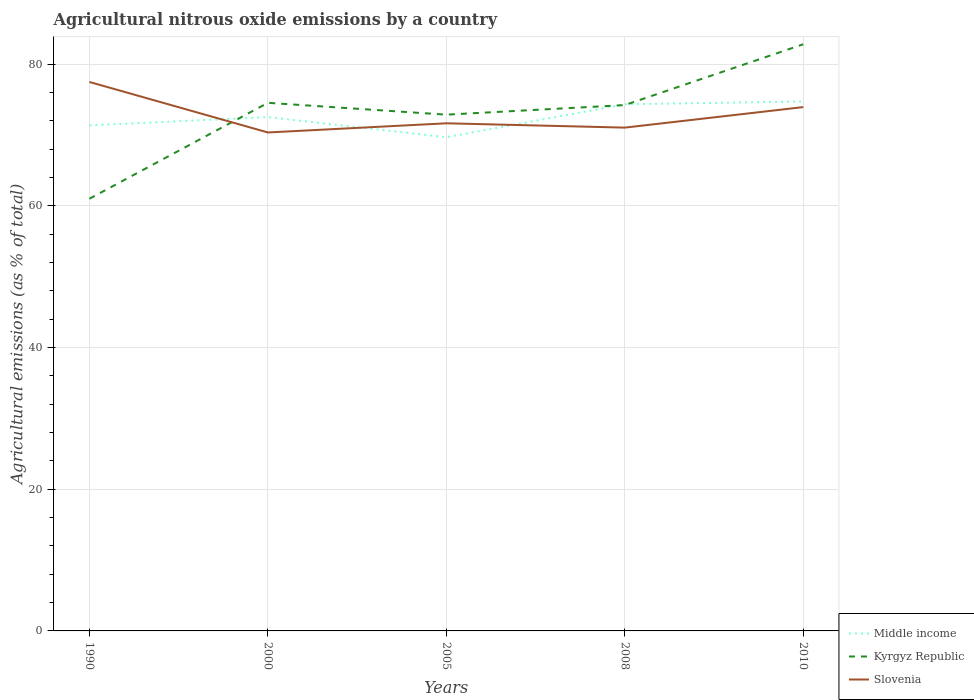How many different coloured lines are there?
Offer a very short reply. 3. Is the number of lines equal to the number of legend labels?
Offer a terse response. Yes. Across all years, what is the maximum amount of agricultural nitrous oxide emitted in Slovenia?
Offer a terse response. 70.37. What is the total amount of agricultural nitrous oxide emitted in Slovenia in the graph?
Your response must be concise. 3.55. What is the difference between the highest and the second highest amount of agricultural nitrous oxide emitted in Kyrgyz Republic?
Your answer should be compact. 21.8. How many years are there in the graph?
Offer a terse response. 5. Does the graph contain any zero values?
Offer a very short reply. No. Does the graph contain grids?
Offer a terse response. Yes. Where does the legend appear in the graph?
Make the answer very short. Bottom right. How many legend labels are there?
Your response must be concise. 3. What is the title of the graph?
Ensure brevity in your answer.  Agricultural nitrous oxide emissions by a country. Does "Guatemala" appear as one of the legend labels in the graph?
Your answer should be compact. No. What is the label or title of the X-axis?
Provide a succinct answer. Years. What is the label or title of the Y-axis?
Keep it short and to the point. Agricultural emissions (as % of total). What is the Agricultural emissions (as % of total) of Middle income in 1990?
Provide a short and direct response. 71.38. What is the Agricultural emissions (as % of total) in Kyrgyz Republic in 1990?
Provide a short and direct response. 61.01. What is the Agricultural emissions (as % of total) in Slovenia in 1990?
Make the answer very short. 77.5. What is the Agricultural emissions (as % of total) in Middle income in 2000?
Provide a succinct answer. 72.54. What is the Agricultural emissions (as % of total) in Kyrgyz Republic in 2000?
Offer a terse response. 74.56. What is the Agricultural emissions (as % of total) in Slovenia in 2000?
Offer a terse response. 70.37. What is the Agricultural emissions (as % of total) of Middle income in 2005?
Ensure brevity in your answer.  69.7. What is the Agricultural emissions (as % of total) of Kyrgyz Republic in 2005?
Your answer should be compact. 72.88. What is the Agricultural emissions (as % of total) in Slovenia in 2005?
Keep it short and to the point. 71.67. What is the Agricultural emissions (as % of total) in Middle income in 2008?
Offer a terse response. 74.35. What is the Agricultural emissions (as % of total) of Kyrgyz Republic in 2008?
Provide a short and direct response. 74.24. What is the Agricultural emissions (as % of total) of Slovenia in 2008?
Ensure brevity in your answer.  71.06. What is the Agricultural emissions (as % of total) in Middle income in 2010?
Ensure brevity in your answer.  74.75. What is the Agricultural emissions (as % of total) in Kyrgyz Republic in 2010?
Give a very brief answer. 82.82. What is the Agricultural emissions (as % of total) in Slovenia in 2010?
Give a very brief answer. 73.95. Across all years, what is the maximum Agricultural emissions (as % of total) in Middle income?
Provide a succinct answer. 74.75. Across all years, what is the maximum Agricultural emissions (as % of total) of Kyrgyz Republic?
Your response must be concise. 82.82. Across all years, what is the maximum Agricultural emissions (as % of total) of Slovenia?
Your answer should be compact. 77.5. Across all years, what is the minimum Agricultural emissions (as % of total) in Middle income?
Provide a short and direct response. 69.7. Across all years, what is the minimum Agricultural emissions (as % of total) of Kyrgyz Republic?
Your answer should be compact. 61.01. Across all years, what is the minimum Agricultural emissions (as % of total) in Slovenia?
Offer a very short reply. 70.37. What is the total Agricultural emissions (as % of total) in Middle income in the graph?
Offer a very short reply. 362.72. What is the total Agricultural emissions (as % of total) of Kyrgyz Republic in the graph?
Your answer should be compact. 365.51. What is the total Agricultural emissions (as % of total) in Slovenia in the graph?
Offer a terse response. 364.55. What is the difference between the Agricultural emissions (as % of total) of Middle income in 1990 and that in 2000?
Your answer should be compact. -1.17. What is the difference between the Agricultural emissions (as % of total) of Kyrgyz Republic in 1990 and that in 2000?
Provide a succinct answer. -13.54. What is the difference between the Agricultural emissions (as % of total) in Slovenia in 1990 and that in 2000?
Offer a very short reply. 7.13. What is the difference between the Agricultural emissions (as % of total) in Middle income in 1990 and that in 2005?
Your response must be concise. 1.68. What is the difference between the Agricultural emissions (as % of total) of Kyrgyz Republic in 1990 and that in 2005?
Ensure brevity in your answer.  -11.87. What is the difference between the Agricultural emissions (as % of total) of Slovenia in 1990 and that in 2005?
Your response must be concise. 5.84. What is the difference between the Agricultural emissions (as % of total) in Middle income in 1990 and that in 2008?
Offer a very short reply. -2.97. What is the difference between the Agricultural emissions (as % of total) of Kyrgyz Republic in 1990 and that in 2008?
Offer a very short reply. -13.22. What is the difference between the Agricultural emissions (as % of total) in Slovenia in 1990 and that in 2008?
Provide a short and direct response. 6.45. What is the difference between the Agricultural emissions (as % of total) in Middle income in 1990 and that in 2010?
Offer a terse response. -3.37. What is the difference between the Agricultural emissions (as % of total) in Kyrgyz Republic in 1990 and that in 2010?
Provide a short and direct response. -21.8. What is the difference between the Agricultural emissions (as % of total) of Slovenia in 1990 and that in 2010?
Provide a succinct answer. 3.55. What is the difference between the Agricultural emissions (as % of total) of Middle income in 2000 and that in 2005?
Your answer should be compact. 2.84. What is the difference between the Agricultural emissions (as % of total) of Kyrgyz Republic in 2000 and that in 2005?
Your answer should be compact. 1.67. What is the difference between the Agricultural emissions (as % of total) of Slovenia in 2000 and that in 2005?
Provide a succinct answer. -1.29. What is the difference between the Agricultural emissions (as % of total) in Middle income in 2000 and that in 2008?
Offer a terse response. -1.8. What is the difference between the Agricultural emissions (as % of total) in Kyrgyz Republic in 2000 and that in 2008?
Give a very brief answer. 0.32. What is the difference between the Agricultural emissions (as % of total) of Slovenia in 2000 and that in 2008?
Your answer should be compact. -0.68. What is the difference between the Agricultural emissions (as % of total) of Middle income in 2000 and that in 2010?
Keep it short and to the point. -2.21. What is the difference between the Agricultural emissions (as % of total) in Kyrgyz Republic in 2000 and that in 2010?
Your answer should be compact. -8.26. What is the difference between the Agricultural emissions (as % of total) in Slovenia in 2000 and that in 2010?
Offer a terse response. -3.58. What is the difference between the Agricultural emissions (as % of total) of Middle income in 2005 and that in 2008?
Your response must be concise. -4.64. What is the difference between the Agricultural emissions (as % of total) in Kyrgyz Republic in 2005 and that in 2008?
Give a very brief answer. -1.35. What is the difference between the Agricultural emissions (as % of total) in Slovenia in 2005 and that in 2008?
Make the answer very short. 0.61. What is the difference between the Agricultural emissions (as % of total) in Middle income in 2005 and that in 2010?
Offer a terse response. -5.05. What is the difference between the Agricultural emissions (as % of total) of Kyrgyz Republic in 2005 and that in 2010?
Make the answer very short. -9.93. What is the difference between the Agricultural emissions (as % of total) in Slovenia in 2005 and that in 2010?
Give a very brief answer. -2.29. What is the difference between the Agricultural emissions (as % of total) in Middle income in 2008 and that in 2010?
Ensure brevity in your answer.  -0.4. What is the difference between the Agricultural emissions (as % of total) of Kyrgyz Republic in 2008 and that in 2010?
Offer a terse response. -8.58. What is the difference between the Agricultural emissions (as % of total) of Slovenia in 2008 and that in 2010?
Provide a short and direct response. -2.9. What is the difference between the Agricultural emissions (as % of total) of Middle income in 1990 and the Agricultural emissions (as % of total) of Kyrgyz Republic in 2000?
Ensure brevity in your answer.  -3.18. What is the difference between the Agricultural emissions (as % of total) of Middle income in 1990 and the Agricultural emissions (as % of total) of Slovenia in 2000?
Offer a terse response. 1.01. What is the difference between the Agricultural emissions (as % of total) of Kyrgyz Republic in 1990 and the Agricultural emissions (as % of total) of Slovenia in 2000?
Keep it short and to the point. -9.36. What is the difference between the Agricultural emissions (as % of total) of Middle income in 1990 and the Agricultural emissions (as % of total) of Kyrgyz Republic in 2005?
Ensure brevity in your answer.  -1.51. What is the difference between the Agricultural emissions (as % of total) in Middle income in 1990 and the Agricultural emissions (as % of total) in Slovenia in 2005?
Offer a terse response. -0.29. What is the difference between the Agricultural emissions (as % of total) in Kyrgyz Republic in 1990 and the Agricultural emissions (as % of total) in Slovenia in 2005?
Your answer should be compact. -10.65. What is the difference between the Agricultural emissions (as % of total) in Middle income in 1990 and the Agricultural emissions (as % of total) in Kyrgyz Republic in 2008?
Your response must be concise. -2.86. What is the difference between the Agricultural emissions (as % of total) in Middle income in 1990 and the Agricultural emissions (as % of total) in Slovenia in 2008?
Offer a very short reply. 0.32. What is the difference between the Agricultural emissions (as % of total) in Kyrgyz Republic in 1990 and the Agricultural emissions (as % of total) in Slovenia in 2008?
Give a very brief answer. -10.04. What is the difference between the Agricultural emissions (as % of total) in Middle income in 1990 and the Agricultural emissions (as % of total) in Kyrgyz Republic in 2010?
Provide a short and direct response. -11.44. What is the difference between the Agricultural emissions (as % of total) in Middle income in 1990 and the Agricultural emissions (as % of total) in Slovenia in 2010?
Provide a short and direct response. -2.57. What is the difference between the Agricultural emissions (as % of total) of Kyrgyz Republic in 1990 and the Agricultural emissions (as % of total) of Slovenia in 2010?
Offer a terse response. -12.94. What is the difference between the Agricultural emissions (as % of total) of Middle income in 2000 and the Agricultural emissions (as % of total) of Kyrgyz Republic in 2005?
Provide a short and direct response. -0.34. What is the difference between the Agricultural emissions (as % of total) of Middle income in 2000 and the Agricultural emissions (as % of total) of Slovenia in 2005?
Give a very brief answer. 0.88. What is the difference between the Agricultural emissions (as % of total) of Kyrgyz Republic in 2000 and the Agricultural emissions (as % of total) of Slovenia in 2005?
Your answer should be compact. 2.89. What is the difference between the Agricultural emissions (as % of total) of Middle income in 2000 and the Agricultural emissions (as % of total) of Kyrgyz Republic in 2008?
Offer a terse response. -1.69. What is the difference between the Agricultural emissions (as % of total) in Middle income in 2000 and the Agricultural emissions (as % of total) in Slovenia in 2008?
Your response must be concise. 1.49. What is the difference between the Agricultural emissions (as % of total) of Kyrgyz Republic in 2000 and the Agricultural emissions (as % of total) of Slovenia in 2008?
Ensure brevity in your answer.  3.5. What is the difference between the Agricultural emissions (as % of total) in Middle income in 2000 and the Agricultural emissions (as % of total) in Kyrgyz Republic in 2010?
Your response must be concise. -10.28. What is the difference between the Agricultural emissions (as % of total) of Middle income in 2000 and the Agricultural emissions (as % of total) of Slovenia in 2010?
Your answer should be very brief. -1.41. What is the difference between the Agricultural emissions (as % of total) of Kyrgyz Republic in 2000 and the Agricultural emissions (as % of total) of Slovenia in 2010?
Ensure brevity in your answer.  0.6. What is the difference between the Agricultural emissions (as % of total) of Middle income in 2005 and the Agricultural emissions (as % of total) of Kyrgyz Republic in 2008?
Your response must be concise. -4.54. What is the difference between the Agricultural emissions (as % of total) in Middle income in 2005 and the Agricultural emissions (as % of total) in Slovenia in 2008?
Your response must be concise. -1.35. What is the difference between the Agricultural emissions (as % of total) of Kyrgyz Republic in 2005 and the Agricultural emissions (as % of total) of Slovenia in 2008?
Keep it short and to the point. 1.83. What is the difference between the Agricultural emissions (as % of total) in Middle income in 2005 and the Agricultural emissions (as % of total) in Kyrgyz Republic in 2010?
Your answer should be very brief. -13.12. What is the difference between the Agricultural emissions (as % of total) of Middle income in 2005 and the Agricultural emissions (as % of total) of Slovenia in 2010?
Your answer should be compact. -4.25. What is the difference between the Agricultural emissions (as % of total) in Kyrgyz Republic in 2005 and the Agricultural emissions (as % of total) in Slovenia in 2010?
Offer a terse response. -1.07. What is the difference between the Agricultural emissions (as % of total) in Middle income in 2008 and the Agricultural emissions (as % of total) in Kyrgyz Republic in 2010?
Offer a terse response. -8.47. What is the difference between the Agricultural emissions (as % of total) in Middle income in 2008 and the Agricultural emissions (as % of total) in Slovenia in 2010?
Ensure brevity in your answer.  0.39. What is the difference between the Agricultural emissions (as % of total) in Kyrgyz Republic in 2008 and the Agricultural emissions (as % of total) in Slovenia in 2010?
Offer a terse response. 0.29. What is the average Agricultural emissions (as % of total) of Middle income per year?
Provide a succinct answer. 72.54. What is the average Agricultural emissions (as % of total) in Kyrgyz Republic per year?
Provide a succinct answer. 73.1. What is the average Agricultural emissions (as % of total) in Slovenia per year?
Make the answer very short. 72.91. In the year 1990, what is the difference between the Agricultural emissions (as % of total) of Middle income and Agricultural emissions (as % of total) of Kyrgyz Republic?
Keep it short and to the point. 10.36. In the year 1990, what is the difference between the Agricultural emissions (as % of total) in Middle income and Agricultural emissions (as % of total) in Slovenia?
Provide a succinct answer. -6.12. In the year 1990, what is the difference between the Agricultural emissions (as % of total) of Kyrgyz Republic and Agricultural emissions (as % of total) of Slovenia?
Provide a succinct answer. -16.49. In the year 2000, what is the difference between the Agricultural emissions (as % of total) in Middle income and Agricultural emissions (as % of total) in Kyrgyz Republic?
Offer a terse response. -2.01. In the year 2000, what is the difference between the Agricultural emissions (as % of total) in Middle income and Agricultural emissions (as % of total) in Slovenia?
Keep it short and to the point. 2.17. In the year 2000, what is the difference between the Agricultural emissions (as % of total) in Kyrgyz Republic and Agricultural emissions (as % of total) in Slovenia?
Your answer should be compact. 4.18. In the year 2005, what is the difference between the Agricultural emissions (as % of total) in Middle income and Agricultural emissions (as % of total) in Kyrgyz Republic?
Make the answer very short. -3.18. In the year 2005, what is the difference between the Agricultural emissions (as % of total) in Middle income and Agricultural emissions (as % of total) in Slovenia?
Your answer should be very brief. -1.96. In the year 2005, what is the difference between the Agricultural emissions (as % of total) in Kyrgyz Republic and Agricultural emissions (as % of total) in Slovenia?
Keep it short and to the point. 1.22. In the year 2008, what is the difference between the Agricultural emissions (as % of total) in Middle income and Agricultural emissions (as % of total) in Kyrgyz Republic?
Your answer should be very brief. 0.11. In the year 2008, what is the difference between the Agricultural emissions (as % of total) of Middle income and Agricultural emissions (as % of total) of Slovenia?
Offer a terse response. 3.29. In the year 2008, what is the difference between the Agricultural emissions (as % of total) in Kyrgyz Republic and Agricultural emissions (as % of total) in Slovenia?
Provide a short and direct response. 3.18. In the year 2010, what is the difference between the Agricultural emissions (as % of total) of Middle income and Agricultural emissions (as % of total) of Kyrgyz Republic?
Offer a terse response. -8.07. In the year 2010, what is the difference between the Agricultural emissions (as % of total) in Middle income and Agricultural emissions (as % of total) in Slovenia?
Keep it short and to the point. 0.8. In the year 2010, what is the difference between the Agricultural emissions (as % of total) of Kyrgyz Republic and Agricultural emissions (as % of total) of Slovenia?
Your answer should be compact. 8.87. What is the ratio of the Agricultural emissions (as % of total) in Middle income in 1990 to that in 2000?
Your answer should be compact. 0.98. What is the ratio of the Agricultural emissions (as % of total) in Kyrgyz Republic in 1990 to that in 2000?
Make the answer very short. 0.82. What is the ratio of the Agricultural emissions (as % of total) in Slovenia in 1990 to that in 2000?
Your answer should be very brief. 1.1. What is the ratio of the Agricultural emissions (as % of total) of Middle income in 1990 to that in 2005?
Offer a terse response. 1.02. What is the ratio of the Agricultural emissions (as % of total) of Kyrgyz Republic in 1990 to that in 2005?
Offer a very short reply. 0.84. What is the ratio of the Agricultural emissions (as % of total) in Slovenia in 1990 to that in 2005?
Provide a short and direct response. 1.08. What is the ratio of the Agricultural emissions (as % of total) of Middle income in 1990 to that in 2008?
Give a very brief answer. 0.96. What is the ratio of the Agricultural emissions (as % of total) in Kyrgyz Republic in 1990 to that in 2008?
Provide a succinct answer. 0.82. What is the ratio of the Agricultural emissions (as % of total) in Slovenia in 1990 to that in 2008?
Give a very brief answer. 1.09. What is the ratio of the Agricultural emissions (as % of total) of Middle income in 1990 to that in 2010?
Your response must be concise. 0.95. What is the ratio of the Agricultural emissions (as % of total) in Kyrgyz Republic in 1990 to that in 2010?
Give a very brief answer. 0.74. What is the ratio of the Agricultural emissions (as % of total) in Slovenia in 1990 to that in 2010?
Provide a short and direct response. 1.05. What is the ratio of the Agricultural emissions (as % of total) of Middle income in 2000 to that in 2005?
Keep it short and to the point. 1.04. What is the ratio of the Agricultural emissions (as % of total) of Kyrgyz Republic in 2000 to that in 2005?
Offer a very short reply. 1.02. What is the ratio of the Agricultural emissions (as % of total) in Middle income in 2000 to that in 2008?
Your answer should be compact. 0.98. What is the ratio of the Agricultural emissions (as % of total) in Kyrgyz Republic in 2000 to that in 2008?
Your answer should be compact. 1. What is the ratio of the Agricultural emissions (as % of total) in Middle income in 2000 to that in 2010?
Offer a very short reply. 0.97. What is the ratio of the Agricultural emissions (as % of total) of Kyrgyz Republic in 2000 to that in 2010?
Provide a short and direct response. 0.9. What is the ratio of the Agricultural emissions (as % of total) of Slovenia in 2000 to that in 2010?
Make the answer very short. 0.95. What is the ratio of the Agricultural emissions (as % of total) in Kyrgyz Republic in 2005 to that in 2008?
Your answer should be compact. 0.98. What is the ratio of the Agricultural emissions (as % of total) in Slovenia in 2005 to that in 2008?
Offer a very short reply. 1.01. What is the ratio of the Agricultural emissions (as % of total) in Middle income in 2005 to that in 2010?
Give a very brief answer. 0.93. What is the ratio of the Agricultural emissions (as % of total) in Kyrgyz Republic in 2005 to that in 2010?
Provide a short and direct response. 0.88. What is the ratio of the Agricultural emissions (as % of total) in Slovenia in 2005 to that in 2010?
Keep it short and to the point. 0.97. What is the ratio of the Agricultural emissions (as % of total) in Kyrgyz Republic in 2008 to that in 2010?
Provide a succinct answer. 0.9. What is the ratio of the Agricultural emissions (as % of total) in Slovenia in 2008 to that in 2010?
Offer a terse response. 0.96. What is the difference between the highest and the second highest Agricultural emissions (as % of total) in Middle income?
Provide a short and direct response. 0.4. What is the difference between the highest and the second highest Agricultural emissions (as % of total) of Kyrgyz Republic?
Provide a short and direct response. 8.26. What is the difference between the highest and the second highest Agricultural emissions (as % of total) in Slovenia?
Your answer should be compact. 3.55. What is the difference between the highest and the lowest Agricultural emissions (as % of total) in Middle income?
Offer a terse response. 5.05. What is the difference between the highest and the lowest Agricultural emissions (as % of total) in Kyrgyz Republic?
Make the answer very short. 21.8. What is the difference between the highest and the lowest Agricultural emissions (as % of total) in Slovenia?
Provide a succinct answer. 7.13. 